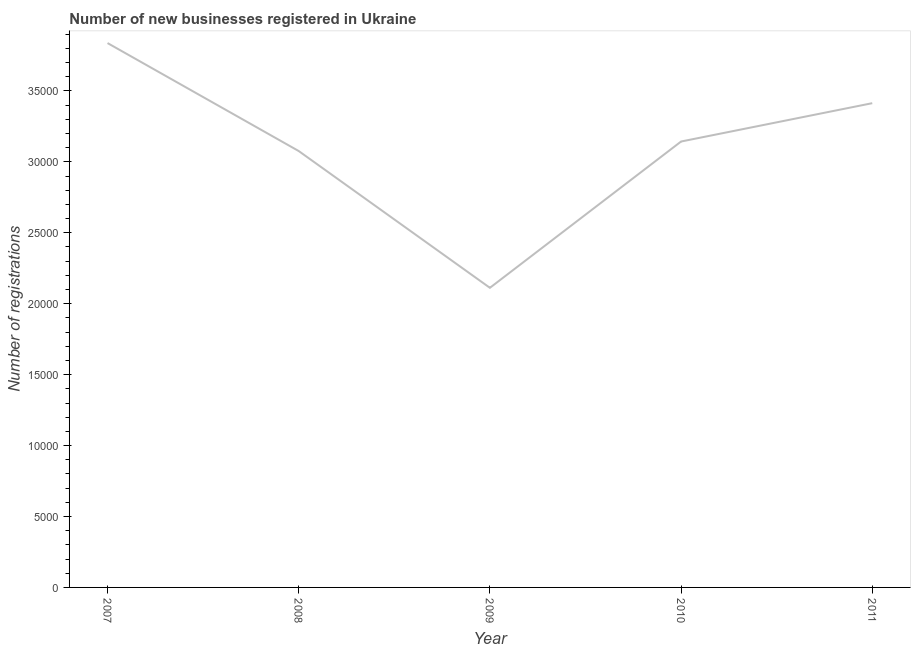What is the number of new business registrations in 2009?
Give a very brief answer. 2.11e+04. Across all years, what is the maximum number of new business registrations?
Make the answer very short. 3.84e+04. Across all years, what is the minimum number of new business registrations?
Offer a very short reply. 2.11e+04. In which year was the number of new business registrations minimum?
Provide a succinct answer. 2009. What is the sum of the number of new business registrations?
Give a very brief answer. 1.56e+05. What is the difference between the number of new business registrations in 2007 and 2010?
Your answer should be very brief. 6940. What is the average number of new business registrations per year?
Your answer should be very brief. 3.12e+04. What is the median number of new business registrations?
Give a very brief answer. 3.14e+04. In how many years, is the number of new business registrations greater than 18000 ?
Keep it short and to the point. 5. What is the ratio of the number of new business registrations in 2009 to that in 2011?
Ensure brevity in your answer.  0.62. Is the difference between the number of new business registrations in 2007 and 2008 greater than the difference between any two years?
Ensure brevity in your answer.  No. What is the difference between the highest and the second highest number of new business registrations?
Your answer should be compact. 4238. What is the difference between the highest and the lowest number of new business registrations?
Provide a short and direct response. 1.73e+04. Does the number of new business registrations monotonically increase over the years?
Offer a very short reply. No. Does the graph contain any zero values?
Ensure brevity in your answer.  No. What is the title of the graph?
Your answer should be compact. Number of new businesses registered in Ukraine. What is the label or title of the Y-axis?
Offer a very short reply. Number of registrations. What is the Number of registrations of 2007?
Your answer should be very brief. 3.84e+04. What is the Number of registrations of 2008?
Make the answer very short. 3.08e+04. What is the Number of registrations of 2009?
Make the answer very short. 2.11e+04. What is the Number of registrations in 2010?
Ensure brevity in your answer.  3.14e+04. What is the Number of registrations of 2011?
Your answer should be compact. 3.41e+04. What is the difference between the Number of registrations in 2007 and 2008?
Your answer should be compact. 7611. What is the difference between the Number of registrations in 2007 and 2009?
Give a very brief answer. 1.73e+04. What is the difference between the Number of registrations in 2007 and 2010?
Your answer should be compact. 6940. What is the difference between the Number of registrations in 2007 and 2011?
Give a very brief answer. 4238. What is the difference between the Number of registrations in 2008 and 2009?
Provide a short and direct response. 9642. What is the difference between the Number of registrations in 2008 and 2010?
Your response must be concise. -671. What is the difference between the Number of registrations in 2008 and 2011?
Provide a short and direct response. -3373. What is the difference between the Number of registrations in 2009 and 2010?
Your response must be concise. -1.03e+04. What is the difference between the Number of registrations in 2009 and 2011?
Your response must be concise. -1.30e+04. What is the difference between the Number of registrations in 2010 and 2011?
Your response must be concise. -2702. What is the ratio of the Number of registrations in 2007 to that in 2008?
Keep it short and to the point. 1.25. What is the ratio of the Number of registrations in 2007 to that in 2009?
Offer a very short reply. 1.82. What is the ratio of the Number of registrations in 2007 to that in 2010?
Make the answer very short. 1.22. What is the ratio of the Number of registrations in 2007 to that in 2011?
Offer a very short reply. 1.12. What is the ratio of the Number of registrations in 2008 to that in 2009?
Keep it short and to the point. 1.46. What is the ratio of the Number of registrations in 2008 to that in 2010?
Make the answer very short. 0.98. What is the ratio of the Number of registrations in 2008 to that in 2011?
Make the answer very short. 0.9. What is the ratio of the Number of registrations in 2009 to that in 2010?
Your answer should be very brief. 0.67. What is the ratio of the Number of registrations in 2009 to that in 2011?
Provide a short and direct response. 0.62. What is the ratio of the Number of registrations in 2010 to that in 2011?
Offer a terse response. 0.92. 